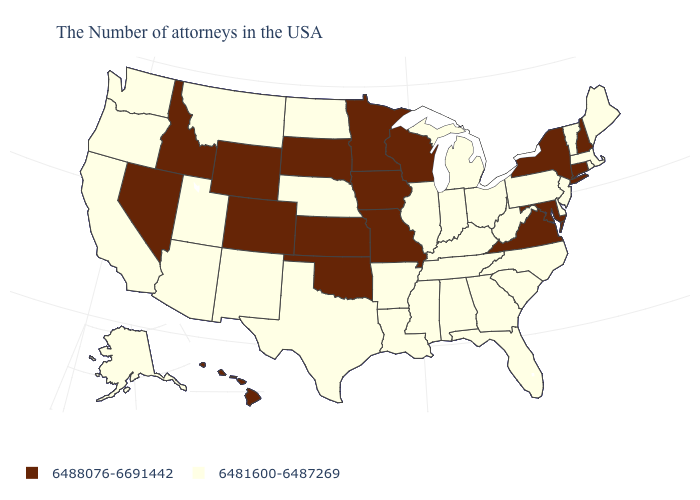Does New York have the highest value in the USA?
Give a very brief answer. Yes. What is the value of South Carolina?
Short answer required. 6481600-6487269. Among the states that border Tennessee , does Virginia have the highest value?
Keep it brief. Yes. What is the value of West Virginia?
Concise answer only. 6481600-6487269. What is the highest value in the USA?
Keep it brief. 6488076-6691442. Among the states that border Texas , which have the lowest value?
Short answer required. Louisiana, Arkansas, New Mexico. Among the states that border Missouri , which have the highest value?
Keep it brief. Iowa, Kansas, Oklahoma. Does Michigan have the lowest value in the USA?
Answer briefly. Yes. What is the lowest value in states that border Maryland?
Give a very brief answer. 6481600-6487269. What is the value of Ohio?
Quick response, please. 6481600-6487269. Does Minnesota have the lowest value in the USA?
Short answer required. No. What is the value of Delaware?
Concise answer only. 6481600-6487269. What is the value of New Hampshire?
Short answer required. 6488076-6691442. 